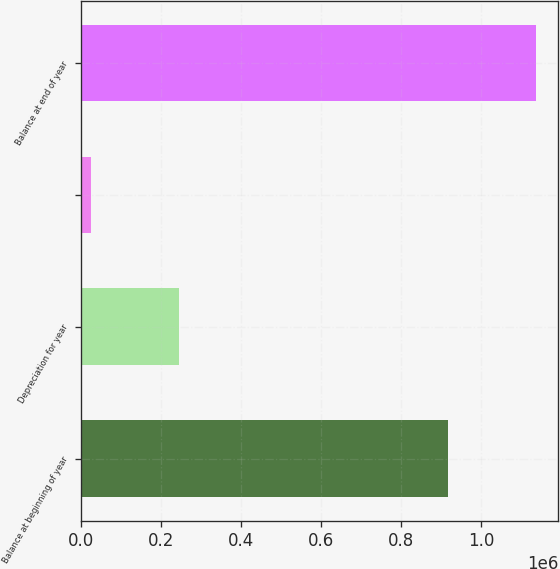Convert chart. <chart><loc_0><loc_0><loc_500><loc_500><bar_chart><fcel>Balance at beginning of year<fcel>Depreciation for year<fcel>Unnamed: 2<fcel>Balance at end of year<nl><fcel>916293<fcel>245421<fcel>25111<fcel>1.1366e+06<nl></chart> 